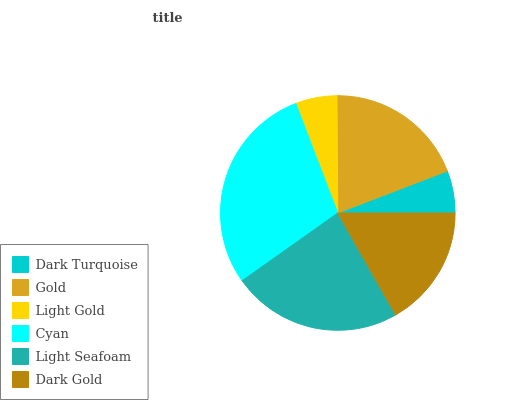Is Light Gold the minimum?
Answer yes or no. Yes. Is Cyan the maximum?
Answer yes or no. Yes. Is Gold the minimum?
Answer yes or no. No. Is Gold the maximum?
Answer yes or no. No. Is Gold greater than Dark Turquoise?
Answer yes or no. Yes. Is Dark Turquoise less than Gold?
Answer yes or no. Yes. Is Dark Turquoise greater than Gold?
Answer yes or no. No. Is Gold less than Dark Turquoise?
Answer yes or no. No. Is Gold the high median?
Answer yes or no. Yes. Is Dark Gold the low median?
Answer yes or no. Yes. Is Dark Gold the high median?
Answer yes or no. No. Is Cyan the low median?
Answer yes or no. No. 